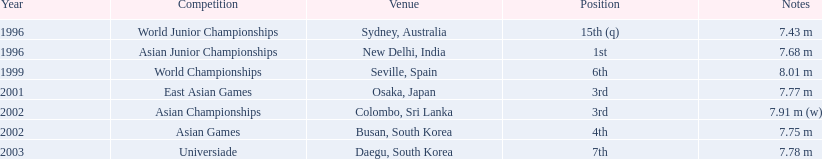What are the various competitions he joined? World Junior Championships, Asian Junior Championships, World Championships, East Asian Games, Asian Championships, Asian Games, Universiade. What were his standings in these events? 15th (q), 1st, 6th, 3rd, 3rd, 4th, 7th. In which particular competition did he attain the 1st spot? Asian Junior Championships. 